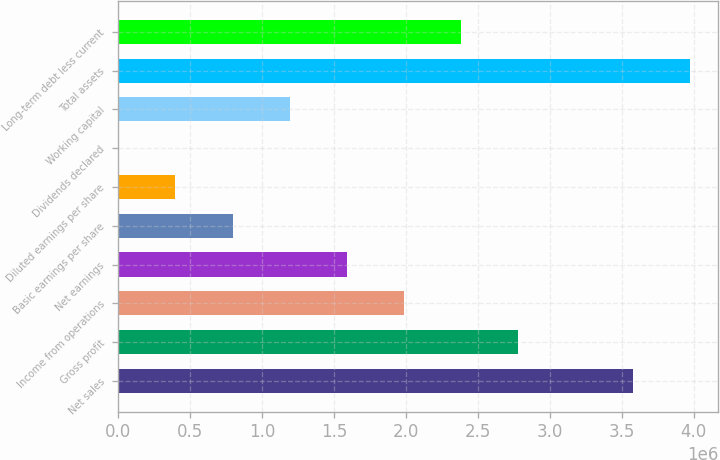Convert chart. <chart><loc_0><loc_0><loc_500><loc_500><bar_chart><fcel>Net sales<fcel>Gross profit<fcel>Income from operations<fcel>Net earnings<fcel>Basic earnings per share<fcel>Diluted earnings per share<fcel>Dividends declared<fcel>Working capital<fcel>Total assets<fcel>Long-term debt less current<nl><fcel>3.57438e+06<fcel>2.78008e+06<fcel>1.98577e+06<fcel>1.58862e+06<fcel>794308<fcel>397154<fcel>0.3<fcel>1.19146e+06<fcel>3.97154e+06<fcel>2.38292e+06<nl></chart> 